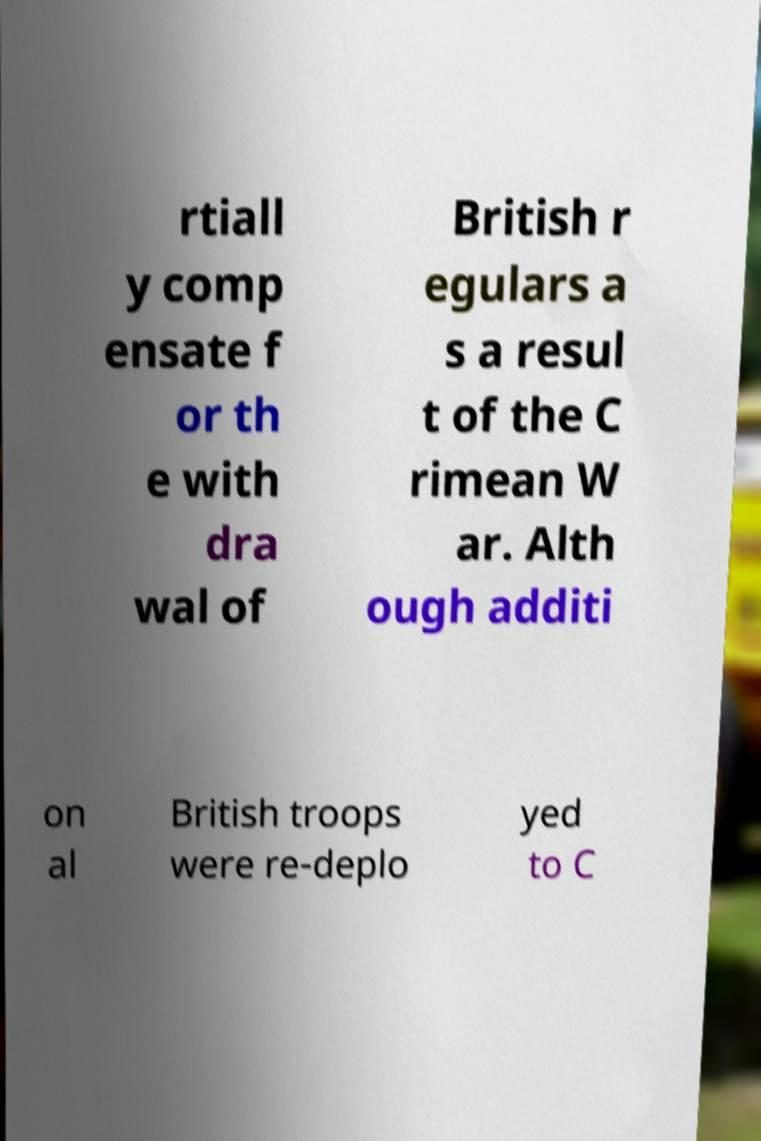What messages or text are displayed in this image? I need them in a readable, typed format. rtiall y comp ensate f or th e with dra wal of British r egulars a s a resul t of the C rimean W ar. Alth ough additi on al British troops were re-deplo yed to C 